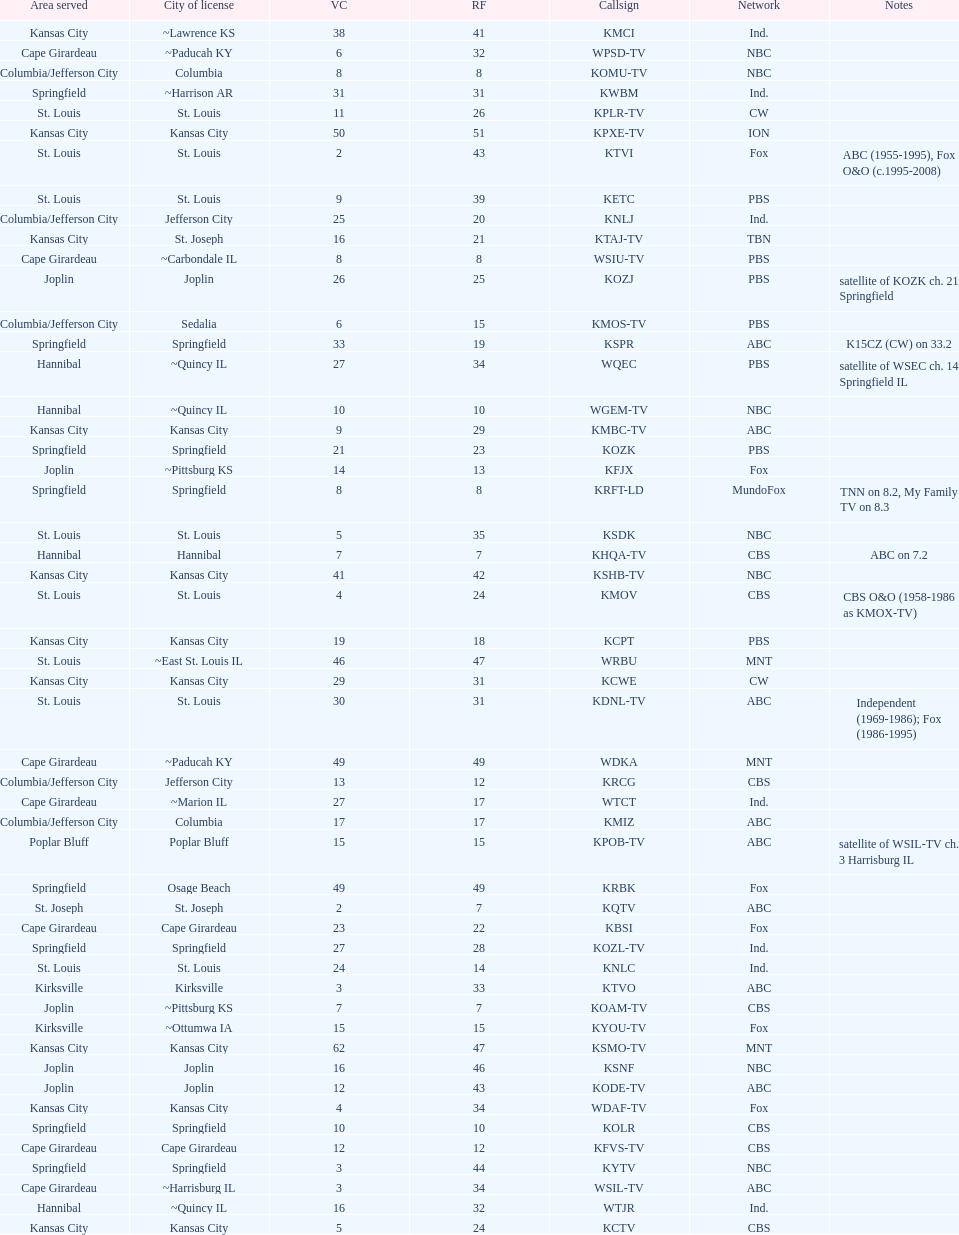How many areas have at least 5 stations? 6. Can you parse all the data within this table? {'header': ['Area served', 'City of license', 'VC', 'RF', 'Callsign', 'Network', 'Notes'], 'rows': [['Kansas City', '~Lawrence KS', '38', '41', 'KMCI', 'Ind.', ''], ['Cape Girardeau', '~Paducah KY', '6', '32', 'WPSD-TV', 'NBC', ''], ['Columbia/Jefferson City', 'Columbia', '8', '8', 'KOMU-TV', 'NBC', ''], ['Springfield', '~Harrison AR', '31', '31', 'KWBM', 'Ind.', ''], ['St. Louis', 'St. Louis', '11', '26', 'KPLR-TV', 'CW', ''], ['Kansas City', 'Kansas City', '50', '51', 'KPXE-TV', 'ION', ''], ['St. Louis', 'St. Louis', '2', '43', 'KTVI', 'Fox', 'ABC (1955-1995), Fox O&O (c.1995-2008)'], ['St. Louis', 'St. Louis', '9', '39', 'KETC', 'PBS', ''], ['Columbia/Jefferson City', 'Jefferson City', '25', '20', 'KNLJ', 'Ind.', ''], ['Kansas City', 'St. Joseph', '16', '21', 'KTAJ-TV', 'TBN', ''], ['Cape Girardeau', '~Carbondale IL', '8', '8', 'WSIU-TV', 'PBS', ''], ['Joplin', 'Joplin', '26', '25', 'KOZJ', 'PBS', 'satellite of KOZK ch. 21 Springfield'], ['Columbia/Jefferson City', 'Sedalia', '6', '15', 'KMOS-TV', 'PBS', ''], ['Springfield', 'Springfield', '33', '19', 'KSPR', 'ABC', 'K15CZ (CW) on 33.2'], ['Hannibal', '~Quincy IL', '27', '34', 'WQEC', 'PBS', 'satellite of WSEC ch. 14 Springfield IL'], ['Hannibal', '~Quincy IL', '10', '10', 'WGEM-TV', 'NBC', ''], ['Kansas City', 'Kansas City', '9', '29', 'KMBC-TV', 'ABC', ''], ['Springfield', 'Springfield', '21', '23', 'KOZK', 'PBS', ''], ['Joplin', '~Pittsburg KS', '14', '13', 'KFJX', 'Fox', ''], ['Springfield', 'Springfield', '8', '8', 'KRFT-LD', 'MundoFox', 'TNN on 8.2, My Family TV on 8.3'], ['St. Louis', 'St. Louis', '5', '35', 'KSDK', 'NBC', ''], ['Hannibal', 'Hannibal', '7', '7', 'KHQA-TV', 'CBS', 'ABC on 7.2'], ['Kansas City', 'Kansas City', '41', '42', 'KSHB-TV', 'NBC', ''], ['St. Louis', 'St. Louis', '4', '24', 'KMOV', 'CBS', 'CBS O&O (1958-1986 as KMOX-TV)'], ['Kansas City', 'Kansas City', '19', '18', 'KCPT', 'PBS', ''], ['St. Louis', '~East St. Louis IL', '46', '47', 'WRBU', 'MNT', ''], ['Kansas City', 'Kansas City', '29', '31', 'KCWE', 'CW', ''], ['St. Louis', 'St. Louis', '30', '31', 'KDNL-TV', 'ABC', 'Independent (1969-1986); Fox (1986-1995)'], ['Cape Girardeau', '~Paducah KY', '49', '49', 'WDKA', 'MNT', ''], ['Columbia/Jefferson City', 'Jefferson City', '13', '12', 'KRCG', 'CBS', ''], ['Cape Girardeau', '~Marion IL', '27', '17', 'WTCT', 'Ind.', ''], ['Columbia/Jefferson City', 'Columbia', '17', '17', 'KMIZ', 'ABC', ''], ['Poplar Bluff', 'Poplar Bluff', '15', '15', 'KPOB-TV', 'ABC', 'satellite of WSIL-TV ch. 3 Harrisburg IL'], ['Springfield', 'Osage Beach', '49', '49', 'KRBK', 'Fox', ''], ['St. Joseph', 'St. Joseph', '2', '7', 'KQTV', 'ABC', ''], ['Cape Girardeau', 'Cape Girardeau', '23', '22', 'KBSI', 'Fox', ''], ['Springfield', 'Springfield', '27', '28', 'KOZL-TV', 'Ind.', ''], ['St. Louis', 'St. Louis', '24', '14', 'KNLC', 'Ind.', ''], ['Kirksville', 'Kirksville', '3', '33', 'KTVO', 'ABC', ''], ['Joplin', '~Pittsburg KS', '7', '7', 'KOAM-TV', 'CBS', ''], ['Kirksville', '~Ottumwa IA', '15', '15', 'KYOU-TV', 'Fox', ''], ['Kansas City', 'Kansas City', '62', '47', 'KSMO-TV', 'MNT', ''], ['Joplin', 'Joplin', '16', '46', 'KSNF', 'NBC', ''], ['Joplin', 'Joplin', '12', '43', 'KODE-TV', 'ABC', ''], ['Kansas City', 'Kansas City', '4', '34', 'WDAF-TV', 'Fox', ''], ['Springfield', 'Springfield', '10', '10', 'KOLR', 'CBS', ''], ['Cape Girardeau', 'Cape Girardeau', '12', '12', 'KFVS-TV', 'CBS', ''], ['Springfield', 'Springfield', '3', '44', 'KYTV', 'NBC', ''], ['Cape Girardeau', '~Harrisburg IL', '3', '34', 'WSIL-TV', 'ABC', ''], ['Hannibal', '~Quincy IL', '16', '32', 'WTJR', 'Ind.', ''], ['Kansas City', 'Kansas City', '5', '24', 'KCTV', 'CBS', '']]} 